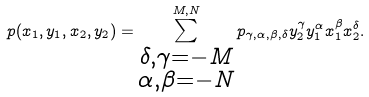<formula> <loc_0><loc_0><loc_500><loc_500>p ( x _ { 1 } , y _ { 1 } , x _ { 2 } , y _ { 2 } ) = \sum _ { \substack { \delta , \gamma = - M \\ \alpha , \beta = - N } } ^ { M , N } p _ { \gamma , \alpha , \beta , \delta } y _ { 2 } ^ { \gamma } y _ { 1 } ^ { \alpha } x _ { 1 } ^ { \beta } x _ { 2 } ^ { \delta } .</formula> 